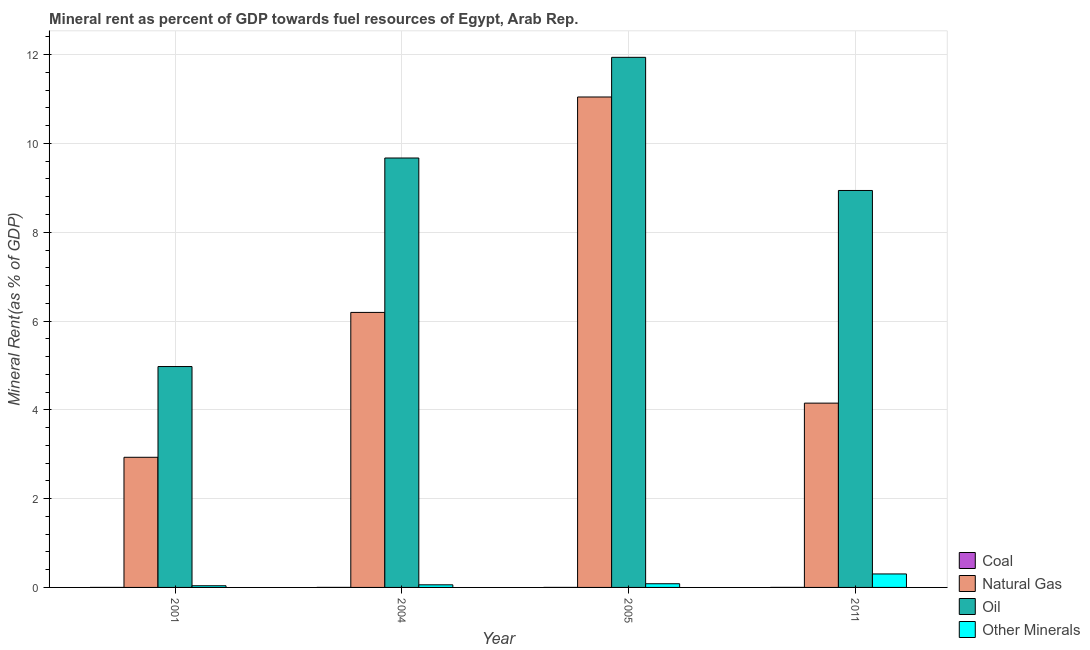How many different coloured bars are there?
Your answer should be compact. 4. How many groups of bars are there?
Provide a succinct answer. 4. How many bars are there on the 1st tick from the left?
Offer a terse response. 4. What is the  rent of other minerals in 2004?
Make the answer very short. 0.06. Across all years, what is the maximum coal rent?
Keep it short and to the point. 0. Across all years, what is the minimum  rent of other minerals?
Your response must be concise. 0.04. What is the total oil rent in the graph?
Your answer should be very brief. 35.53. What is the difference between the  rent of other minerals in 2005 and that in 2011?
Your response must be concise. -0.22. What is the difference between the  rent of other minerals in 2005 and the natural gas rent in 2011?
Your answer should be very brief. -0.22. What is the average coal rent per year?
Your response must be concise. 0. In the year 2005, what is the difference between the natural gas rent and oil rent?
Your answer should be compact. 0. What is the ratio of the  rent of other minerals in 2005 to that in 2011?
Keep it short and to the point. 0.27. Is the difference between the oil rent in 2001 and 2011 greater than the difference between the  rent of other minerals in 2001 and 2011?
Make the answer very short. No. What is the difference between the highest and the second highest oil rent?
Your response must be concise. 2.27. What is the difference between the highest and the lowest natural gas rent?
Keep it short and to the point. 8.12. Is it the case that in every year, the sum of the oil rent and  rent of other minerals is greater than the sum of coal rent and natural gas rent?
Offer a terse response. No. What does the 2nd bar from the left in 2001 represents?
Make the answer very short. Natural Gas. What does the 1st bar from the right in 2001 represents?
Your answer should be compact. Other Minerals. Is it the case that in every year, the sum of the coal rent and natural gas rent is greater than the oil rent?
Make the answer very short. No. Does the graph contain any zero values?
Keep it short and to the point. No. Does the graph contain grids?
Provide a succinct answer. Yes. What is the title of the graph?
Make the answer very short. Mineral rent as percent of GDP towards fuel resources of Egypt, Arab Rep. Does "Overall level" appear as one of the legend labels in the graph?
Offer a terse response. No. What is the label or title of the Y-axis?
Provide a short and direct response. Mineral Rent(as % of GDP). What is the Mineral Rent(as % of GDP) of Coal in 2001?
Offer a terse response. 1.02739128441411e-6. What is the Mineral Rent(as % of GDP) of Natural Gas in 2001?
Offer a very short reply. 2.93. What is the Mineral Rent(as % of GDP) of Oil in 2001?
Provide a short and direct response. 4.98. What is the Mineral Rent(as % of GDP) of Other Minerals in 2001?
Your response must be concise. 0.04. What is the Mineral Rent(as % of GDP) in Coal in 2004?
Make the answer very short. 0. What is the Mineral Rent(as % of GDP) in Natural Gas in 2004?
Your response must be concise. 6.19. What is the Mineral Rent(as % of GDP) of Oil in 2004?
Provide a succinct answer. 9.67. What is the Mineral Rent(as % of GDP) in Other Minerals in 2004?
Ensure brevity in your answer.  0.06. What is the Mineral Rent(as % of GDP) in Coal in 2005?
Give a very brief answer. 0. What is the Mineral Rent(as % of GDP) of Natural Gas in 2005?
Provide a succinct answer. 11.05. What is the Mineral Rent(as % of GDP) in Oil in 2005?
Provide a succinct answer. 11.94. What is the Mineral Rent(as % of GDP) in Other Minerals in 2005?
Your answer should be very brief. 0.08. What is the Mineral Rent(as % of GDP) of Coal in 2011?
Offer a very short reply. 0. What is the Mineral Rent(as % of GDP) in Natural Gas in 2011?
Ensure brevity in your answer.  4.15. What is the Mineral Rent(as % of GDP) of Oil in 2011?
Give a very brief answer. 8.94. What is the Mineral Rent(as % of GDP) of Other Minerals in 2011?
Provide a short and direct response. 0.3. Across all years, what is the maximum Mineral Rent(as % of GDP) in Coal?
Offer a terse response. 0. Across all years, what is the maximum Mineral Rent(as % of GDP) of Natural Gas?
Provide a short and direct response. 11.05. Across all years, what is the maximum Mineral Rent(as % of GDP) of Oil?
Your answer should be compact. 11.94. Across all years, what is the maximum Mineral Rent(as % of GDP) in Other Minerals?
Offer a terse response. 0.3. Across all years, what is the minimum Mineral Rent(as % of GDP) of Coal?
Ensure brevity in your answer.  1.02739128441411e-6. Across all years, what is the minimum Mineral Rent(as % of GDP) of Natural Gas?
Provide a succinct answer. 2.93. Across all years, what is the minimum Mineral Rent(as % of GDP) of Oil?
Your answer should be compact. 4.98. Across all years, what is the minimum Mineral Rent(as % of GDP) in Other Minerals?
Provide a short and direct response. 0.04. What is the total Mineral Rent(as % of GDP) in Coal in the graph?
Give a very brief answer. 0. What is the total Mineral Rent(as % of GDP) of Natural Gas in the graph?
Make the answer very short. 24.32. What is the total Mineral Rent(as % of GDP) in Oil in the graph?
Your answer should be compact. 35.53. What is the total Mineral Rent(as % of GDP) of Other Minerals in the graph?
Your answer should be very brief. 0.48. What is the difference between the Mineral Rent(as % of GDP) in Coal in 2001 and that in 2004?
Make the answer very short. -0. What is the difference between the Mineral Rent(as % of GDP) in Natural Gas in 2001 and that in 2004?
Keep it short and to the point. -3.26. What is the difference between the Mineral Rent(as % of GDP) of Oil in 2001 and that in 2004?
Keep it short and to the point. -4.7. What is the difference between the Mineral Rent(as % of GDP) of Other Minerals in 2001 and that in 2004?
Ensure brevity in your answer.  -0.02. What is the difference between the Mineral Rent(as % of GDP) in Coal in 2001 and that in 2005?
Provide a succinct answer. -0. What is the difference between the Mineral Rent(as % of GDP) in Natural Gas in 2001 and that in 2005?
Ensure brevity in your answer.  -8.12. What is the difference between the Mineral Rent(as % of GDP) of Oil in 2001 and that in 2005?
Provide a short and direct response. -6.96. What is the difference between the Mineral Rent(as % of GDP) of Other Minerals in 2001 and that in 2005?
Make the answer very short. -0.05. What is the difference between the Mineral Rent(as % of GDP) in Coal in 2001 and that in 2011?
Offer a very short reply. -0. What is the difference between the Mineral Rent(as % of GDP) of Natural Gas in 2001 and that in 2011?
Your answer should be very brief. -1.22. What is the difference between the Mineral Rent(as % of GDP) of Oil in 2001 and that in 2011?
Offer a terse response. -3.97. What is the difference between the Mineral Rent(as % of GDP) of Other Minerals in 2001 and that in 2011?
Ensure brevity in your answer.  -0.27. What is the difference between the Mineral Rent(as % of GDP) in Natural Gas in 2004 and that in 2005?
Provide a succinct answer. -4.85. What is the difference between the Mineral Rent(as % of GDP) of Oil in 2004 and that in 2005?
Keep it short and to the point. -2.27. What is the difference between the Mineral Rent(as % of GDP) of Other Minerals in 2004 and that in 2005?
Offer a terse response. -0.02. What is the difference between the Mineral Rent(as % of GDP) of Natural Gas in 2004 and that in 2011?
Ensure brevity in your answer.  2.04. What is the difference between the Mineral Rent(as % of GDP) in Oil in 2004 and that in 2011?
Your response must be concise. 0.73. What is the difference between the Mineral Rent(as % of GDP) of Other Minerals in 2004 and that in 2011?
Your answer should be compact. -0.24. What is the difference between the Mineral Rent(as % of GDP) in Coal in 2005 and that in 2011?
Your answer should be very brief. -0. What is the difference between the Mineral Rent(as % of GDP) in Natural Gas in 2005 and that in 2011?
Offer a very short reply. 6.9. What is the difference between the Mineral Rent(as % of GDP) in Oil in 2005 and that in 2011?
Provide a short and direct response. 3. What is the difference between the Mineral Rent(as % of GDP) of Other Minerals in 2005 and that in 2011?
Your answer should be very brief. -0.22. What is the difference between the Mineral Rent(as % of GDP) in Coal in 2001 and the Mineral Rent(as % of GDP) in Natural Gas in 2004?
Ensure brevity in your answer.  -6.19. What is the difference between the Mineral Rent(as % of GDP) in Coal in 2001 and the Mineral Rent(as % of GDP) in Oil in 2004?
Offer a very short reply. -9.67. What is the difference between the Mineral Rent(as % of GDP) in Coal in 2001 and the Mineral Rent(as % of GDP) in Other Minerals in 2004?
Offer a terse response. -0.06. What is the difference between the Mineral Rent(as % of GDP) of Natural Gas in 2001 and the Mineral Rent(as % of GDP) of Oil in 2004?
Provide a succinct answer. -6.74. What is the difference between the Mineral Rent(as % of GDP) of Natural Gas in 2001 and the Mineral Rent(as % of GDP) of Other Minerals in 2004?
Your response must be concise. 2.87. What is the difference between the Mineral Rent(as % of GDP) in Oil in 2001 and the Mineral Rent(as % of GDP) in Other Minerals in 2004?
Make the answer very short. 4.92. What is the difference between the Mineral Rent(as % of GDP) of Coal in 2001 and the Mineral Rent(as % of GDP) of Natural Gas in 2005?
Your answer should be very brief. -11.05. What is the difference between the Mineral Rent(as % of GDP) in Coal in 2001 and the Mineral Rent(as % of GDP) in Oil in 2005?
Your answer should be very brief. -11.94. What is the difference between the Mineral Rent(as % of GDP) of Coal in 2001 and the Mineral Rent(as % of GDP) of Other Minerals in 2005?
Offer a very short reply. -0.08. What is the difference between the Mineral Rent(as % of GDP) in Natural Gas in 2001 and the Mineral Rent(as % of GDP) in Oil in 2005?
Ensure brevity in your answer.  -9.01. What is the difference between the Mineral Rent(as % of GDP) of Natural Gas in 2001 and the Mineral Rent(as % of GDP) of Other Minerals in 2005?
Offer a terse response. 2.85. What is the difference between the Mineral Rent(as % of GDP) of Oil in 2001 and the Mineral Rent(as % of GDP) of Other Minerals in 2005?
Give a very brief answer. 4.89. What is the difference between the Mineral Rent(as % of GDP) of Coal in 2001 and the Mineral Rent(as % of GDP) of Natural Gas in 2011?
Offer a terse response. -4.15. What is the difference between the Mineral Rent(as % of GDP) in Coal in 2001 and the Mineral Rent(as % of GDP) in Oil in 2011?
Keep it short and to the point. -8.94. What is the difference between the Mineral Rent(as % of GDP) of Coal in 2001 and the Mineral Rent(as % of GDP) of Other Minerals in 2011?
Keep it short and to the point. -0.3. What is the difference between the Mineral Rent(as % of GDP) in Natural Gas in 2001 and the Mineral Rent(as % of GDP) in Oil in 2011?
Offer a terse response. -6.01. What is the difference between the Mineral Rent(as % of GDP) in Natural Gas in 2001 and the Mineral Rent(as % of GDP) in Other Minerals in 2011?
Offer a terse response. 2.63. What is the difference between the Mineral Rent(as % of GDP) of Oil in 2001 and the Mineral Rent(as % of GDP) of Other Minerals in 2011?
Offer a terse response. 4.67. What is the difference between the Mineral Rent(as % of GDP) in Coal in 2004 and the Mineral Rent(as % of GDP) in Natural Gas in 2005?
Keep it short and to the point. -11.05. What is the difference between the Mineral Rent(as % of GDP) in Coal in 2004 and the Mineral Rent(as % of GDP) in Oil in 2005?
Offer a terse response. -11.94. What is the difference between the Mineral Rent(as % of GDP) of Coal in 2004 and the Mineral Rent(as % of GDP) of Other Minerals in 2005?
Ensure brevity in your answer.  -0.08. What is the difference between the Mineral Rent(as % of GDP) of Natural Gas in 2004 and the Mineral Rent(as % of GDP) of Oil in 2005?
Your response must be concise. -5.75. What is the difference between the Mineral Rent(as % of GDP) of Natural Gas in 2004 and the Mineral Rent(as % of GDP) of Other Minerals in 2005?
Offer a terse response. 6.11. What is the difference between the Mineral Rent(as % of GDP) in Oil in 2004 and the Mineral Rent(as % of GDP) in Other Minerals in 2005?
Keep it short and to the point. 9.59. What is the difference between the Mineral Rent(as % of GDP) of Coal in 2004 and the Mineral Rent(as % of GDP) of Natural Gas in 2011?
Provide a succinct answer. -4.15. What is the difference between the Mineral Rent(as % of GDP) in Coal in 2004 and the Mineral Rent(as % of GDP) in Oil in 2011?
Provide a short and direct response. -8.94. What is the difference between the Mineral Rent(as % of GDP) of Coal in 2004 and the Mineral Rent(as % of GDP) of Other Minerals in 2011?
Your answer should be very brief. -0.3. What is the difference between the Mineral Rent(as % of GDP) in Natural Gas in 2004 and the Mineral Rent(as % of GDP) in Oil in 2011?
Make the answer very short. -2.75. What is the difference between the Mineral Rent(as % of GDP) of Natural Gas in 2004 and the Mineral Rent(as % of GDP) of Other Minerals in 2011?
Keep it short and to the point. 5.89. What is the difference between the Mineral Rent(as % of GDP) of Oil in 2004 and the Mineral Rent(as % of GDP) of Other Minerals in 2011?
Keep it short and to the point. 9.37. What is the difference between the Mineral Rent(as % of GDP) in Coal in 2005 and the Mineral Rent(as % of GDP) in Natural Gas in 2011?
Keep it short and to the point. -4.15. What is the difference between the Mineral Rent(as % of GDP) of Coal in 2005 and the Mineral Rent(as % of GDP) of Oil in 2011?
Provide a succinct answer. -8.94. What is the difference between the Mineral Rent(as % of GDP) of Coal in 2005 and the Mineral Rent(as % of GDP) of Other Minerals in 2011?
Ensure brevity in your answer.  -0.3. What is the difference between the Mineral Rent(as % of GDP) of Natural Gas in 2005 and the Mineral Rent(as % of GDP) of Oil in 2011?
Your response must be concise. 2.11. What is the difference between the Mineral Rent(as % of GDP) in Natural Gas in 2005 and the Mineral Rent(as % of GDP) in Other Minerals in 2011?
Ensure brevity in your answer.  10.74. What is the difference between the Mineral Rent(as % of GDP) in Oil in 2005 and the Mineral Rent(as % of GDP) in Other Minerals in 2011?
Provide a short and direct response. 11.64. What is the average Mineral Rent(as % of GDP) in Natural Gas per year?
Offer a terse response. 6.08. What is the average Mineral Rent(as % of GDP) in Oil per year?
Your response must be concise. 8.88. What is the average Mineral Rent(as % of GDP) in Other Minerals per year?
Keep it short and to the point. 0.12. In the year 2001, what is the difference between the Mineral Rent(as % of GDP) of Coal and Mineral Rent(as % of GDP) of Natural Gas?
Your answer should be compact. -2.93. In the year 2001, what is the difference between the Mineral Rent(as % of GDP) in Coal and Mineral Rent(as % of GDP) in Oil?
Offer a terse response. -4.98. In the year 2001, what is the difference between the Mineral Rent(as % of GDP) of Coal and Mineral Rent(as % of GDP) of Other Minerals?
Offer a very short reply. -0.04. In the year 2001, what is the difference between the Mineral Rent(as % of GDP) of Natural Gas and Mineral Rent(as % of GDP) of Oil?
Offer a very short reply. -2.04. In the year 2001, what is the difference between the Mineral Rent(as % of GDP) of Natural Gas and Mineral Rent(as % of GDP) of Other Minerals?
Provide a short and direct response. 2.89. In the year 2001, what is the difference between the Mineral Rent(as % of GDP) in Oil and Mineral Rent(as % of GDP) in Other Minerals?
Give a very brief answer. 4.94. In the year 2004, what is the difference between the Mineral Rent(as % of GDP) of Coal and Mineral Rent(as % of GDP) of Natural Gas?
Make the answer very short. -6.19. In the year 2004, what is the difference between the Mineral Rent(as % of GDP) in Coal and Mineral Rent(as % of GDP) in Oil?
Your answer should be compact. -9.67. In the year 2004, what is the difference between the Mineral Rent(as % of GDP) in Coal and Mineral Rent(as % of GDP) in Other Minerals?
Your answer should be compact. -0.06. In the year 2004, what is the difference between the Mineral Rent(as % of GDP) in Natural Gas and Mineral Rent(as % of GDP) in Oil?
Your answer should be very brief. -3.48. In the year 2004, what is the difference between the Mineral Rent(as % of GDP) in Natural Gas and Mineral Rent(as % of GDP) in Other Minerals?
Your answer should be compact. 6.14. In the year 2004, what is the difference between the Mineral Rent(as % of GDP) of Oil and Mineral Rent(as % of GDP) of Other Minerals?
Offer a terse response. 9.61. In the year 2005, what is the difference between the Mineral Rent(as % of GDP) in Coal and Mineral Rent(as % of GDP) in Natural Gas?
Your response must be concise. -11.05. In the year 2005, what is the difference between the Mineral Rent(as % of GDP) in Coal and Mineral Rent(as % of GDP) in Oil?
Provide a short and direct response. -11.94. In the year 2005, what is the difference between the Mineral Rent(as % of GDP) of Coal and Mineral Rent(as % of GDP) of Other Minerals?
Provide a short and direct response. -0.08. In the year 2005, what is the difference between the Mineral Rent(as % of GDP) of Natural Gas and Mineral Rent(as % of GDP) of Oil?
Your response must be concise. -0.89. In the year 2005, what is the difference between the Mineral Rent(as % of GDP) in Natural Gas and Mineral Rent(as % of GDP) in Other Minerals?
Ensure brevity in your answer.  10.96. In the year 2005, what is the difference between the Mineral Rent(as % of GDP) of Oil and Mineral Rent(as % of GDP) of Other Minerals?
Ensure brevity in your answer.  11.86. In the year 2011, what is the difference between the Mineral Rent(as % of GDP) in Coal and Mineral Rent(as % of GDP) in Natural Gas?
Ensure brevity in your answer.  -4.15. In the year 2011, what is the difference between the Mineral Rent(as % of GDP) in Coal and Mineral Rent(as % of GDP) in Oil?
Offer a very short reply. -8.94. In the year 2011, what is the difference between the Mineral Rent(as % of GDP) of Coal and Mineral Rent(as % of GDP) of Other Minerals?
Your response must be concise. -0.3. In the year 2011, what is the difference between the Mineral Rent(as % of GDP) in Natural Gas and Mineral Rent(as % of GDP) in Oil?
Keep it short and to the point. -4.79. In the year 2011, what is the difference between the Mineral Rent(as % of GDP) of Natural Gas and Mineral Rent(as % of GDP) of Other Minerals?
Provide a short and direct response. 3.85. In the year 2011, what is the difference between the Mineral Rent(as % of GDP) in Oil and Mineral Rent(as % of GDP) in Other Minerals?
Make the answer very short. 8.64. What is the ratio of the Mineral Rent(as % of GDP) in Coal in 2001 to that in 2004?
Offer a terse response. 0. What is the ratio of the Mineral Rent(as % of GDP) in Natural Gas in 2001 to that in 2004?
Offer a terse response. 0.47. What is the ratio of the Mineral Rent(as % of GDP) of Oil in 2001 to that in 2004?
Offer a very short reply. 0.51. What is the ratio of the Mineral Rent(as % of GDP) in Other Minerals in 2001 to that in 2004?
Your response must be concise. 0.64. What is the ratio of the Mineral Rent(as % of GDP) of Coal in 2001 to that in 2005?
Keep it short and to the point. 0. What is the ratio of the Mineral Rent(as % of GDP) in Natural Gas in 2001 to that in 2005?
Offer a terse response. 0.27. What is the ratio of the Mineral Rent(as % of GDP) of Oil in 2001 to that in 2005?
Keep it short and to the point. 0.42. What is the ratio of the Mineral Rent(as % of GDP) of Other Minerals in 2001 to that in 2005?
Ensure brevity in your answer.  0.45. What is the ratio of the Mineral Rent(as % of GDP) of Coal in 2001 to that in 2011?
Offer a very short reply. 0. What is the ratio of the Mineral Rent(as % of GDP) of Natural Gas in 2001 to that in 2011?
Offer a very short reply. 0.71. What is the ratio of the Mineral Rent(as % of GDP) of Oil in 2001 to that in 2011?
Offer a terse response. 0.56. What is the ratio of the Mineral Rent(as % of GDP) of Other Minerals in 2001 to that in 2011?
Offer a terse response. 0.12. What is the ratio of the Mineral Rent(as % of GDP) of Coal in 2004 to that in 2005?
Provide a succinct answer. 2.83. What is the ratio of the Mineral Rent(as % of GDP) in Natural Gas in 2004 to that in 2005?
Your answer should be very brief. 0.56. What is the ratio of the Mineral Rent(as % of GDP) of Oil in 2004 to that in 2005?
Offer a terse response. 0.81. What is the ratio of the Mineral Rent(as % of GDP) in Other Minerals in 2004 to that in 2005?
Keep it short and to the point. 0.71. What is the ratio of the Mineral Rent(as % of GDP) of Coal in 2004 to that in 2011?
Provide a succinct answer. 1.13. What is the ratio of the Mineral Rent(as % of GDP) in Natural Gas in 2004 to that in 2011?
Ensure brevity in your answer.  1.49. What is the ratio of the Mineral Rent(as % of GDP) in Oil in 2004 to that in 2011?
Your answer should be very brief. 1.08. What is the ratio of the Mineral Rent(as % of GDP) of Other Minerals in 2004 to that in 2011?
Provide a short and direct response. 0.19. What is the ratio of the Mineral Rent(as % of GDP) of Coal in 2005 to that in 2011?
Your answer should be very brief. 0.4. What is the ratio of the Mineral Rent(as % of GDP) of Natural Gas in 2005 to that in 2011?
Offer a very short reply. 2.66. What is the ratio of the Mineral Rent(as % of GDP) in Oil in 2005 to that in 2011?
Give a very brief answer. 1.34. What is the ratio of the Mineral Rent(as % of GDP) of Other Minerals in 2005 to that in 2011?
Your answer should be very brief. 0.27. What is the difference between the highest and the second highest Mineral Rent(as % of GDP) in Coal?
Provide a short and direct response. 0. What is the difference between the highest and the second highest Mineral Rent(as % of GDP) of Natural Gas?
Provide a succinct answer. 4.85. What is the difference between the highest and the second highest Mineral Rent(as % of GDP) in Oil?
Provide a short and direct response. 2.27. What is the difference between the highest and the second highest Mineral Rent(as % of GDP) in Other Minerals?
Make the answer very short. 0.22. What is the difference between the highest and the lowest Mineral Rent(as % of GDP) of Coal?
Keep it short and to the point. 0. What is the difference between the highest and the lowest Mineral Rent(as % of GDP) of Natural Gas?
Keep it short and to the point. 8.12. What is the difference between the highest and the lowest Mineral Rent(as % of GDP) in Oil?
Your response must be concise. 6.96. What is the difference between the highest and the lowest Mineral Rent(as % of GDP) of Other Minerals?
Offer a terse response. 0.27. 